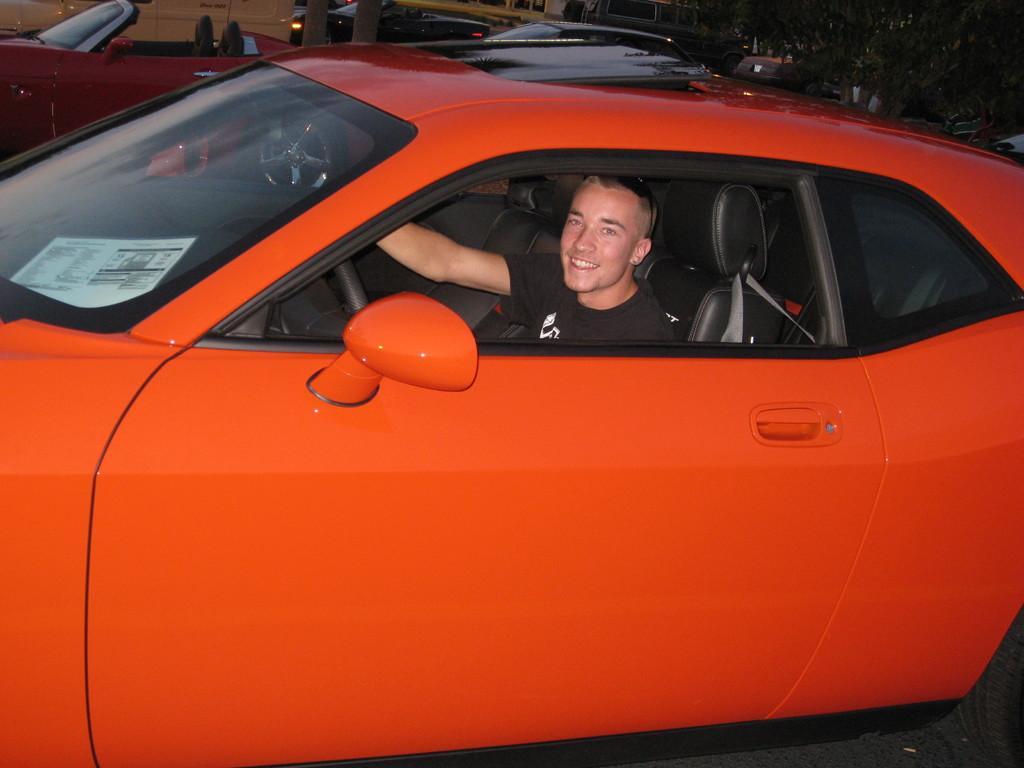Could you give a brief overview of what you see in this image? In the image we can see there is orange colour car in which there is a person who is sitting and he is holding the steering and beside there are other cars which are parked on the road and behind there are lot of trees. 